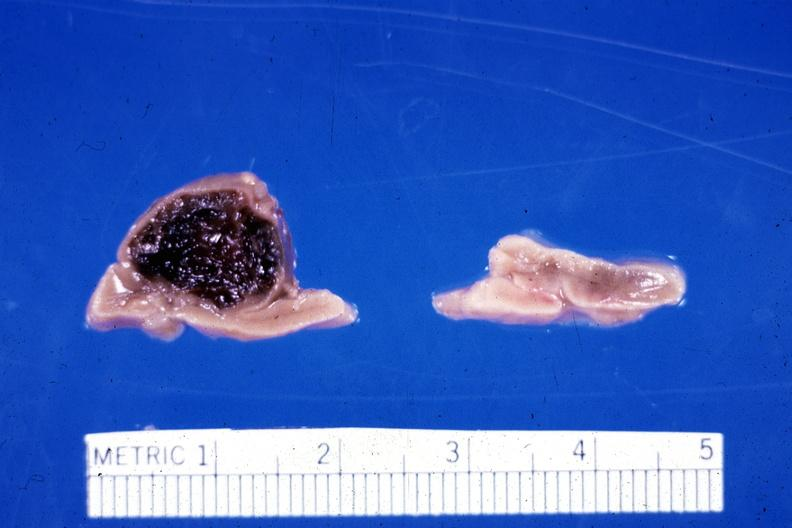what is present?
Answer the question using a single word or phrase. Endocrine 